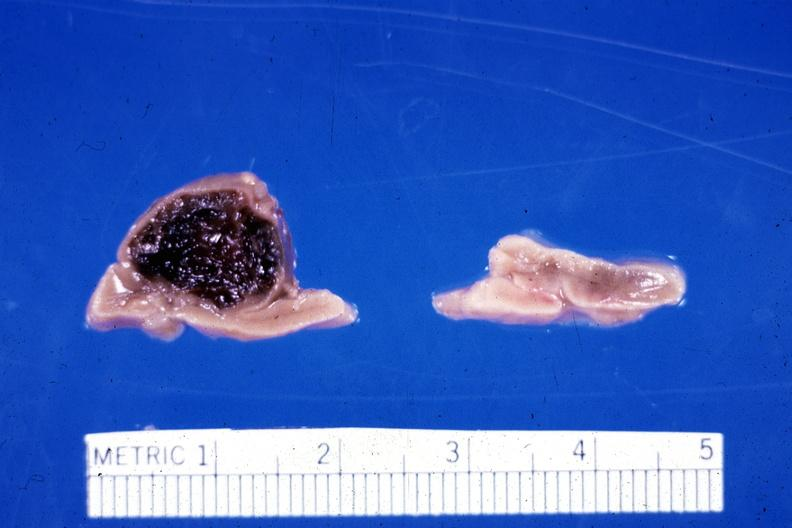what is present?
Answer the question using a single word or phrase. Endocrine 